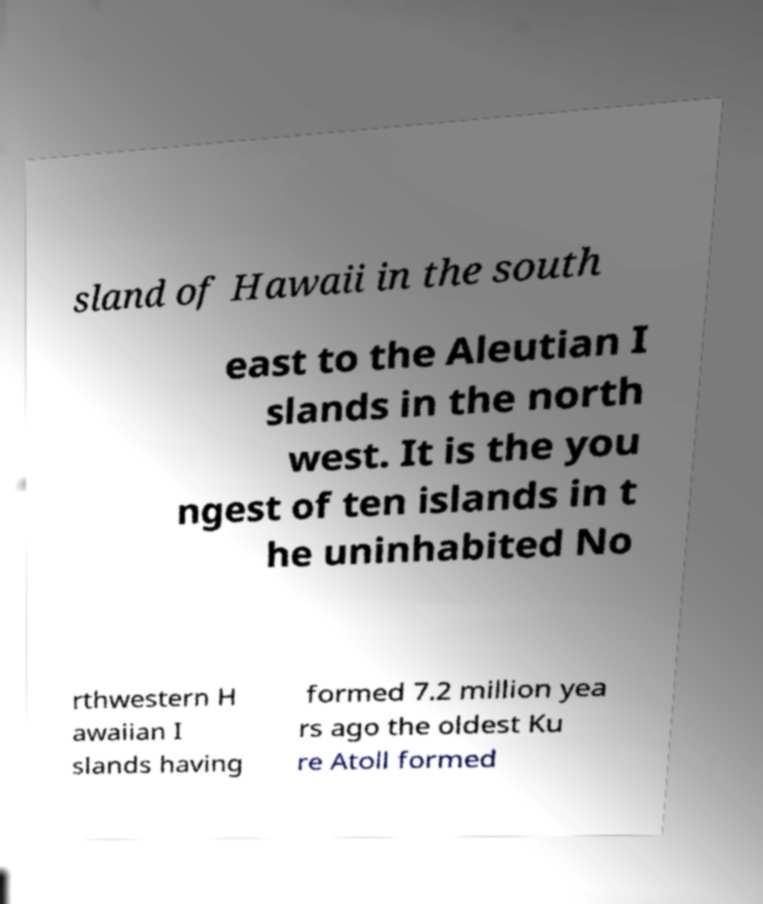For documentation purposes, I need the text within this image transcribed. Could you provide that? sland of Hawaii in the south east to the Aleutian I slands in the north west. It is the you ngest of ten islands in t he uninhabited No rthwestern H awaiian I slands having formed 7.2 million yea rs ago the oldest Ku re Atoll formed 